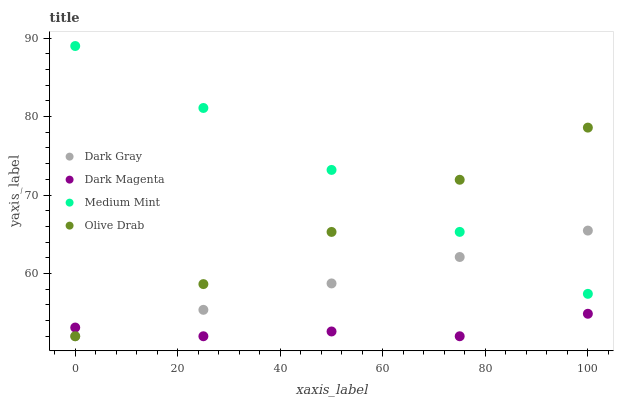Does Dark Magenta have the minimum area under the curve?
Answer yes or no. Yes. Does Medium Mint have the maximum area under the curve?
Answer yes or no. Yes. Does Medium Mint have the minimum area under the curve?
Answer yes or no. No. Does Dark Magenta have the maximum area under the curve?
Answer yes or no. No. Is Olive Drab the smoothest?
Answer yes or no. Yes. Is Dark Magenta the roughest?
Answer yes or no. Yes. Is Medium Mint the smoothest?
Answer yes or no. No. Is Medium Mint the roughest?
Answer yes or no. No. Does Dark Gray have the lowest value?
Answer yes or no. Yes. Does Medium Mint have the lowest value?
Answer yes or no. No. Does Medium Mint have the highest value?
Answer yes or no. Yes. Does Dark Magenta have the highest value?
Answer yes or no. No. Is Dark Magenta less than Medium Mint?
Answer yes or no. Yes. Is Medium Mint greater than Dark Magenta?
Answer yes or no. Yes. Does Dark Magenta intersect Dark Gray?
Answer yes or no. Yes. Is Dark Magenta less than Dark Gray?
Answer yes or no. No. Is Dark Magenta greater than Dark Gray?
Answer yes or no. No. Does Dark Magenta intersect Medium Mint?
Answer yes or no. No. 